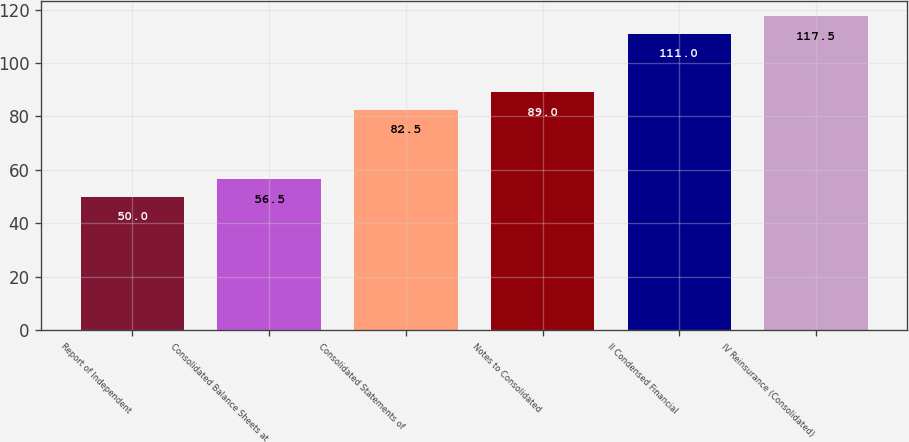Convert chart. <chart><loc_0><loc_0><loc_500><loc_500><bar_chart><fcel>Report of Independent<fcel>Consolidated Balance Sheets at<fcel>Consolidated Statements of<fcel>Notes to Consolidated<fcel>II Condensed Financial<fcel>IV Reinsurance (Consolidated)<nl><fcel>50<fcel>56.5<fcel>82.5<fcel>89<fcel>111<fcel>117.5<nl></chart> 